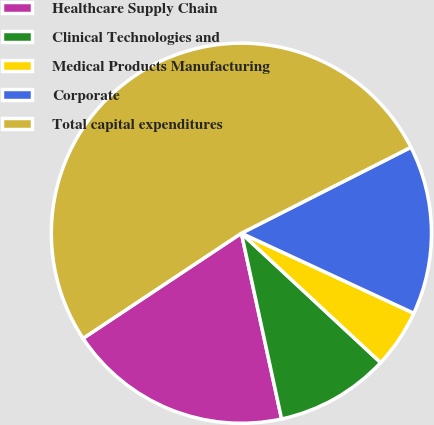Convert chart to OTSL. <chart><loc_0><loc_0><loc_500><loc_500><pie_chart><fcel>Healthcare Supply Chain<fcel>Clinical Technologies and<fcel>Medical Products Manufacturing<fcel>Corporate<fcel>Total capital expenditures<nl><fcel>19.06%<fcel>9.69%<fcel>5.0%<fcel>14.38%<fcel>51.86%<nl></chart> 